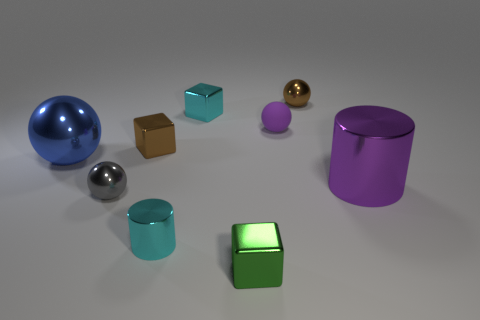There is a small thing that is the same color as the large metallic cylinder; what is its shape?
Your answer should be very brief. Sphere. What number of gray spheres have the same size as the gray thing?
Keep it short and to the point. 0. How many big objects are on the right side of the small cylinder?
Offer a terse response. 1. What material is the tiny brown thing in front of the small metallic ball that is to the right of the green metal cube made of?
Your response must be concise. Metal. Are there any small cubes that have the same color as the small metallic cylinder?
Keep it short and to the point. Yes. The purple object that is the same material as the gray sphere is what size?
Offer a terse response. Large. Is there anything else of the same color as the large metallic sphere?
Give a very brief answer. No. What is the color of the small metal sphere that is to the right of the small purple thing?
Make the answer very short. Brown. Are there any large purple cylinders that are on the left side of the cube that is in front of the gray sphere behind the green cube?
Ensure brevity in your answer.  No. Are there more purple metal things in front of the small brown block than tiny cyan metallic blocks?
Offer a terse response. No. 